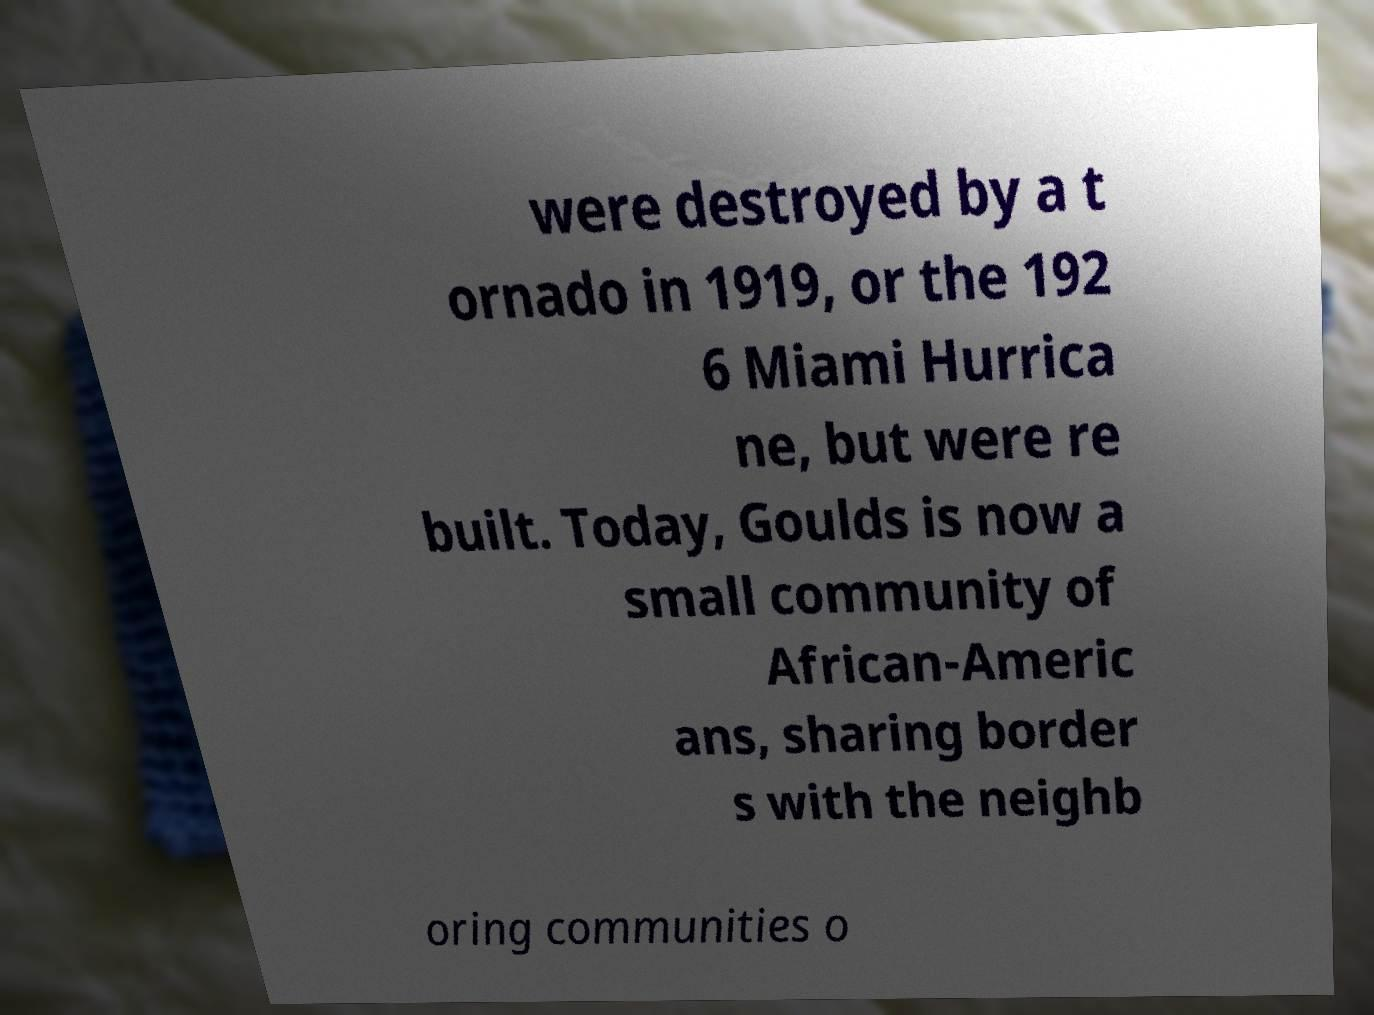I need the written content from this picture converted into text. Can you do that? were destroyed by a t ornado in 1919, or the 192 6 Miami Hurrica ne, but were re built. Today, Goulds is now a small community of African-Americ ans, sharing border s with the neighb oring communities o 